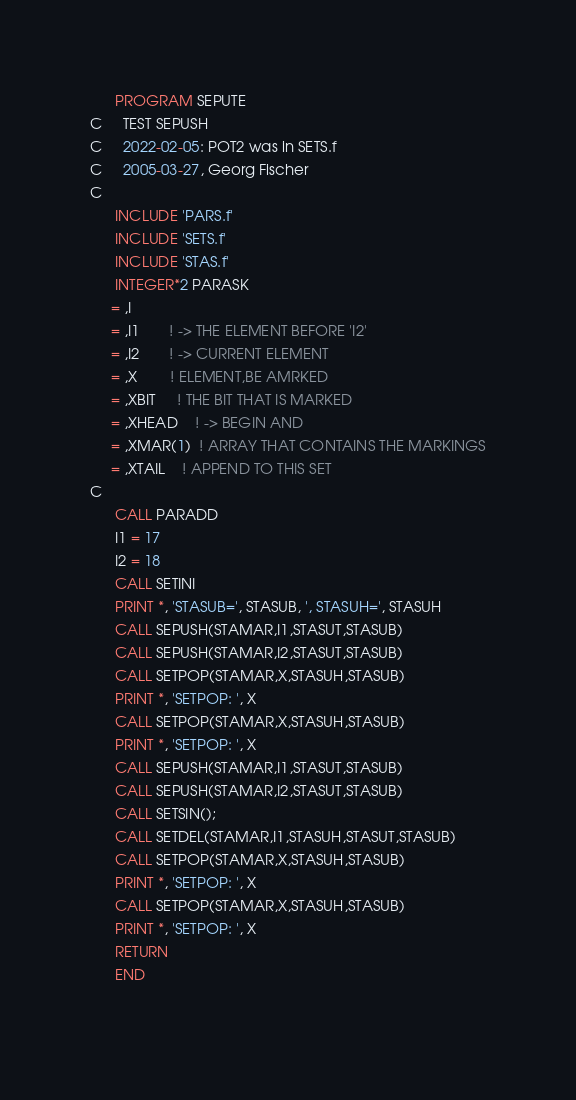Convert code to text. <code><loc_0><loc_0><loc_500><loc_500><_FORTRAN_>      PROGRAM SEPUTE
C     TEST SEPUSH
C     2022-02-05: POT2 was in SETS.f
C     2005-03-27, Georg Fischer
C
      INCLUDE 'PARS.f'
      INCLUDE 'SETS.f'
      INCLUDE 'STAS.f'
      INTEGER*2 PARASK
     = ,I
     = ,I1       ! -> THE ELEMENT BEFORE 'I2'
     = ,I2       ! -> CURRENT ELEMENT
     = ,X        ! ELEMENT,BE AMRKED
     = ,XBIT     ! THE BIT THAT IS MARKED
     = ,XHEAD    ! -> BEGIN AND
     = ,XMAR(1)  ! ARRAY THAT CONTAINS THE MARKINGS
     = ,XTAIL    ! APPEND TO THIS SET
C
      CALL PARADD
      I1 = 17
      I2 = 18
      CALL SETINI
      PRINT *, 'STASUB=', STASUB, ', STASUH=', STASUH
      CALL SEPUSH(STAMAR,I1,STASUT,STASUB)
      CALL SEPUSH(STAMAR,I2,STASUT,STASUB)
      CALL SETPOP(STAMAR,X,STASUH,STASUB)
      PRINT *, 'SETPOP: ', X
      CALL SETPOP(STAMAR,X,STASUH,STASUB)
      PRINT *, 'SETPOP: ', X
      CALL SEPUSH(STAMAR,I1,STASUT,STASUB)
      CALL SEPUSH(STAMAR,I2,STASUT,STASUB)
      CALL SETSIN();
      CALL SETDEL(STAMAR,I1,STASUH,STASUT,STASUB)
      CALL SETPOP(STAMAR,X,STASUH,STASUB)
      PRINT *, 'SETPOP: ', X
      CALL SETPOP(STAMAR,X,STASUH,STASUB)
      PRINT *, 'SETPOP: ', X
      RETURN
      END
      </code> 